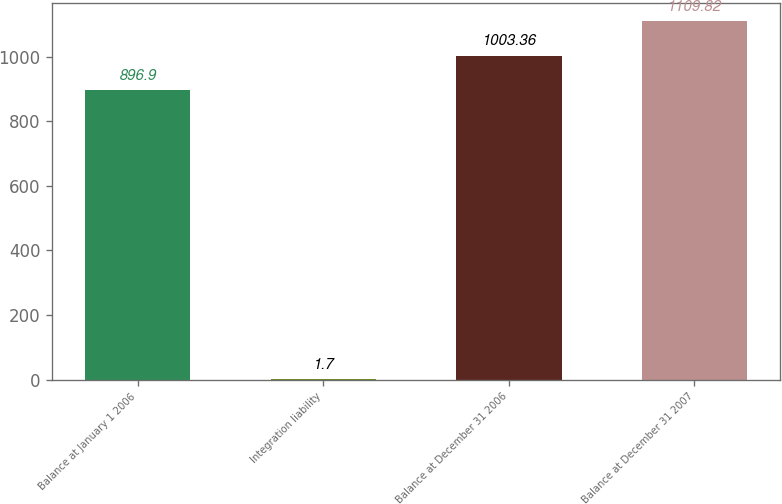Convert chart to OTSL. <chart><loc_0><loc_0><loc_500><loc_500><bar_chart><fcel>Balance at January 1 2006<fcel>Integration liability<fcel>Balance at December 31 2006<fcel>Balance at December 31 2007<nl><fcel>896.9<fcel>1.7<fcel>1003.36<fcel>1109.82<nl></chart> 